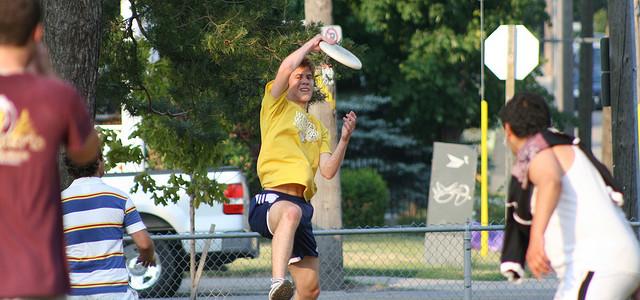What is the man in the yellow shirt catching?
Answer briefly. Frisbee. What kind of fence is this?
Short answer required. Chain link. What color is the frisbee?
Answer briefly. White. What sport is shown?
Give a very brief answer. Frisbee. Is the kid skateboarding?
Keep it brief. No. What are they playing?
Write a very short answer. Frisbee. 